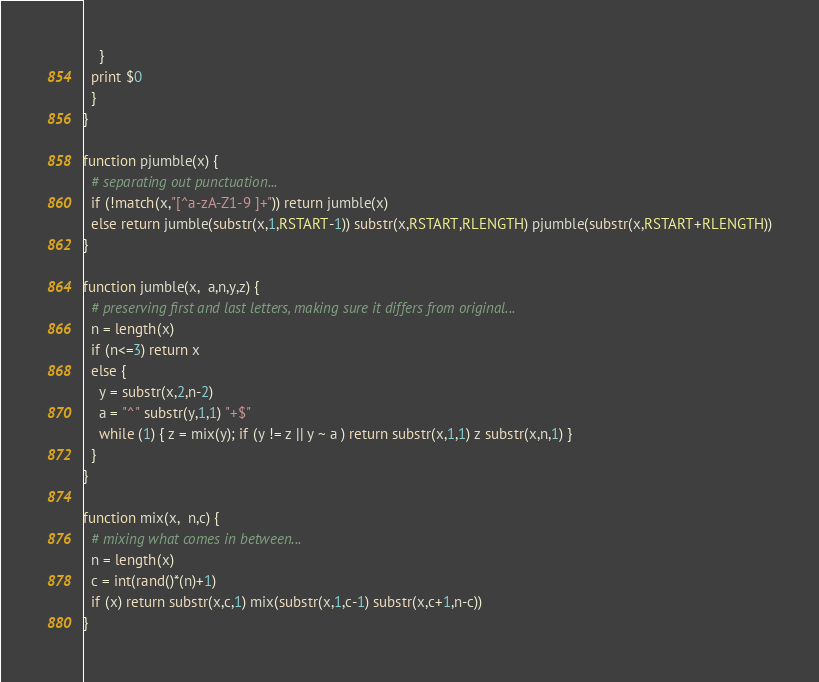Convert code to text. <code><loc_0><loc_0><loc_500><loc_500><_Awk_>    }
  print $0
  }
}

function pjumble(x) {
  # separating out punctuation...
  if (!match(x,"[^a-zA-Z1-9 ]+")) return jumble(x)
  else return jumble(substr(x,1,RSTART-1)) substr(x,RSTART,RLENGTH) pjumble(substr(x,RSTART+RLENGTH))
}

function jumble(x,  a,n,y,z) {
  # preserving first and last letters, making sure it differs from original...
  n = length(x)
  if (n<=3) return x
  else {
    y = substr(x,2,n-2)
    a = "^" substr(y,1,1) "+$"
    while (1) { z = mix(y); if (y != z || y ~ a ) return substr(x,1,1) z substr(x,n,1) }
  }
}

function mix(x,  n,c) {
  # mixing what comes in between...
  n = length(x)
  c = int(rand()*(n)+1)
  if (x) return substr(x,c,1) mix(substr(x,1,c-1) substr(x,c+1,n-c))
}</code> 